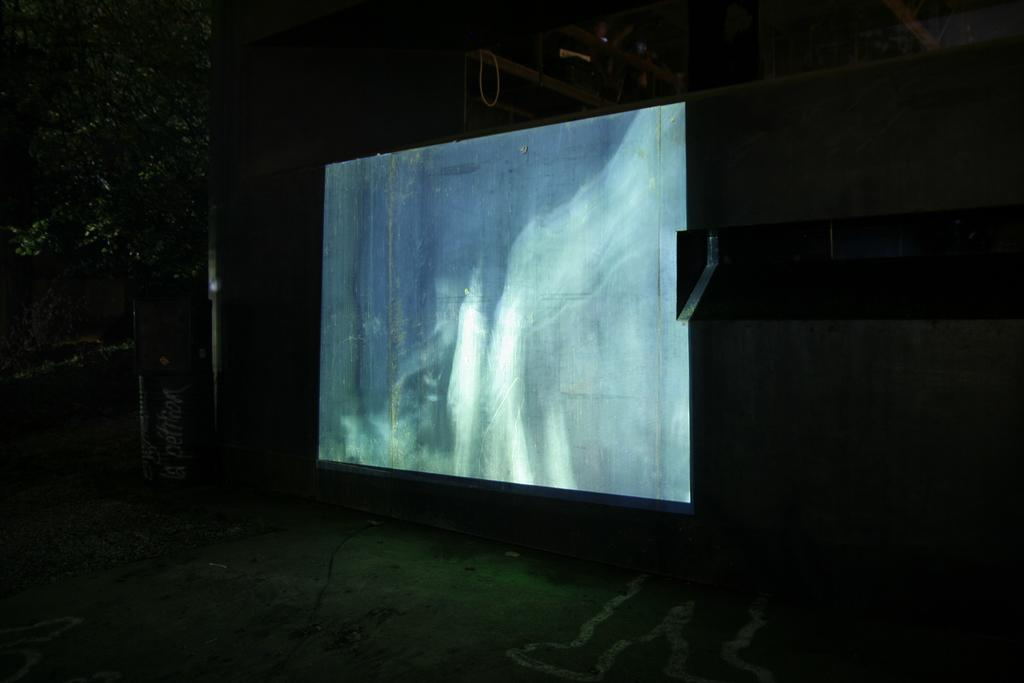What is on the wall in the image? There is a screen on the wall in the image. What can be seen near the wall? There is a tree near the wall in the image. What object is also near the wall? There is a drum near the wall in the image. What is on top of the drum? Something is on the drum in the image. How does the salt affect the magic in the image? There is no salt or magic present in the image. What type of crack is visible on the tree in the image? There is no crack visible on the tree in the image. 